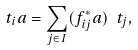<formula> <loc_0><loc_0><loc_500><loc_500>\ t _ { i } a = \sum _ { j \in I } ( f _ { i j } ^ { * } a ) \ t _ { j } ,</formula> 